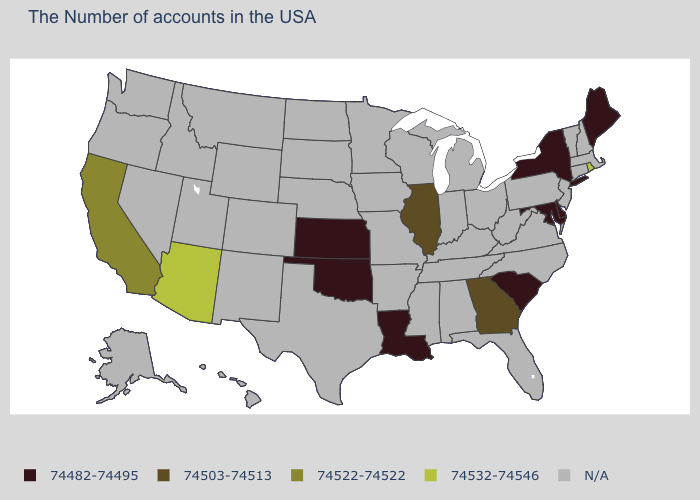Among the states that border Tennessee , which have the highest value?
Answer briefly. Georgia. What is the value of New York?
Give a very brief answer. 74482-74495. Which states have the highest value in the USA?
Quick response, please. Rhode Island, Arizona. Name the states that have a value in the range 74482-74495?
Quick response, please. Maine, New York, Delaware, Maryland, South Carolina, Louisiana, Kansas, Oklahoma. Does the map have missing data?
Be succinct. Yes. Does Arizona have the lowest value in the West?
Quick response, please. No. Does Georgia have the lowest value in the USA?
Short answer required. No. What is the lowest value in the USA?
Keep it brief. 74482-74495. Which states have the lowest value in the USA?
Write a very short answer. Maine, New York, Delaware, Maryland, South Carolina, Louisiana, Kansas, Oklahoma. Does Arizona have the lowest value in the West?
Be succinct. No. What is the highest value in the South ?
Give a very brief answer. 74503-74513. What is the value of Ohio?
Give a very brief answer. N/A. 